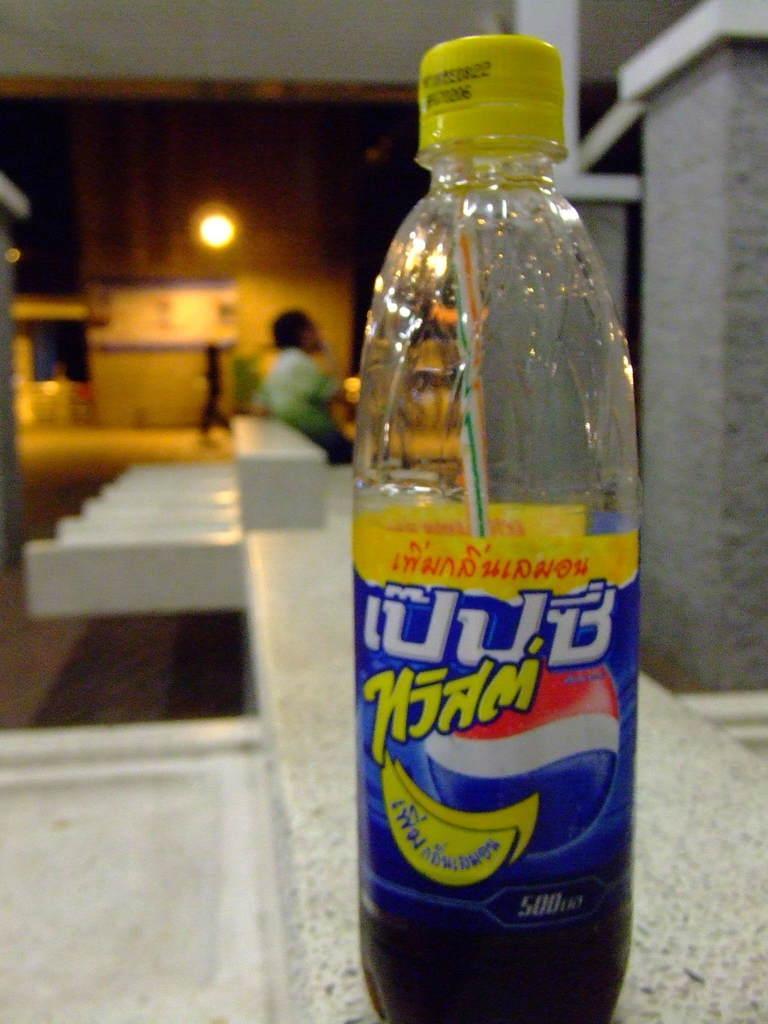In one or two sentences, can you explain what this image depicts? In this image we can see a cool drink bottle and a person on the top left. 